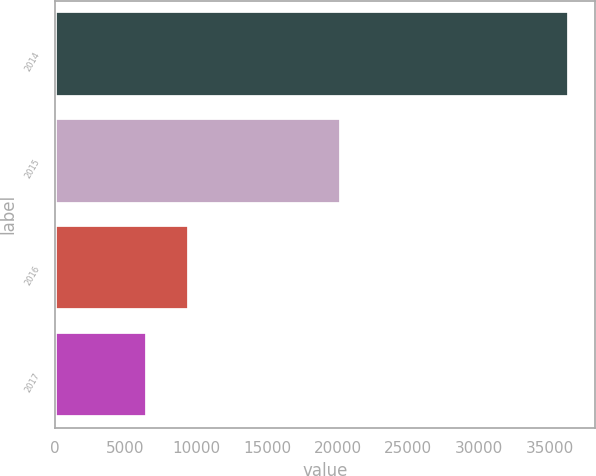<chart> <loc_0><loc_0><loc_500><loc_500><bar_chart><fcel>2014<fcel>2015<fcel>2016<fcel>2017<nl><fcel>36368<fcel>20207<fcel>9496.7<fcel>6511<nl></chart> 